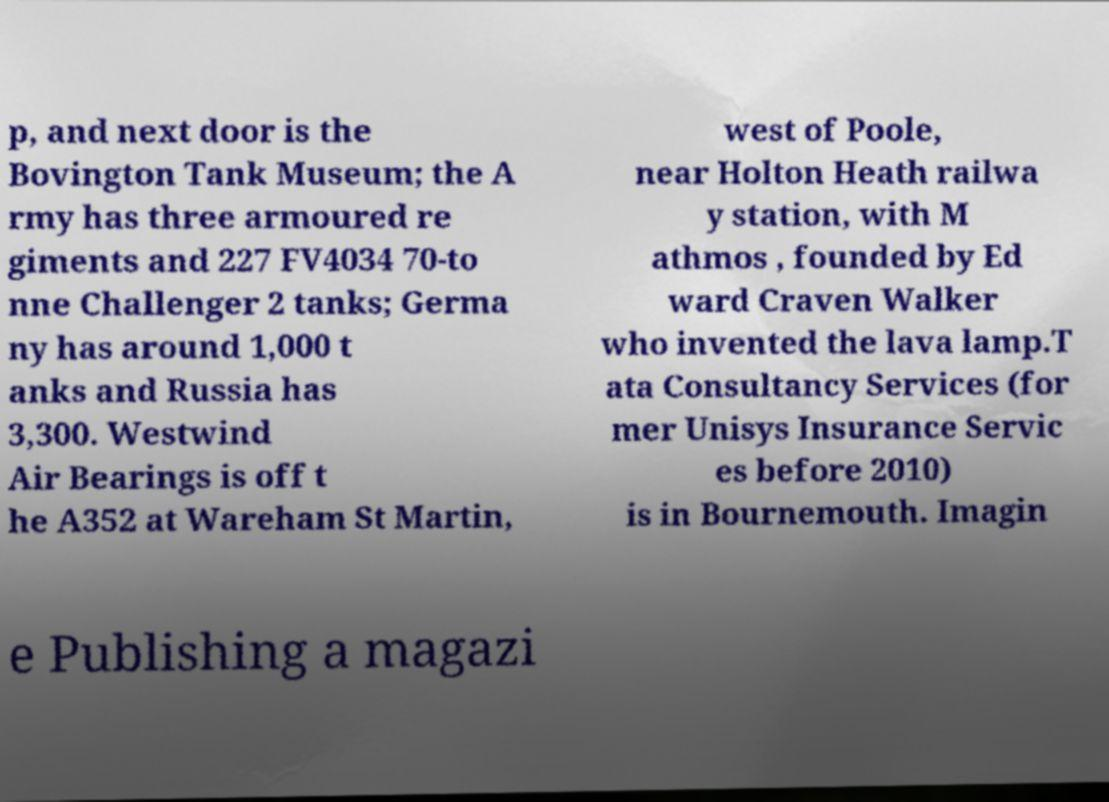Can you read and provide the text displayed in the image?This photo seems to have some interesting text. Can you extract and type it out for me? p, and next door is the Bovington Tank Museum; the A rmy has three armoured re giments and 227 FV4034 70-to nne Challenger 2 tanks; Germa ny has around 1,000 t anks and Russia has 3,300. Westwind Air Bearings is off t he A352 at Wareham St Martin, west of Poole, near Holton Heath railwa y station, with M athmos , founded by Ed ward Craven Walker who invented the lava lamp.T ata Consultancy Services (for mer Unisys Insurance Servic es before 2010) is in Bournemouth. Imagin e Publishing a magazi 